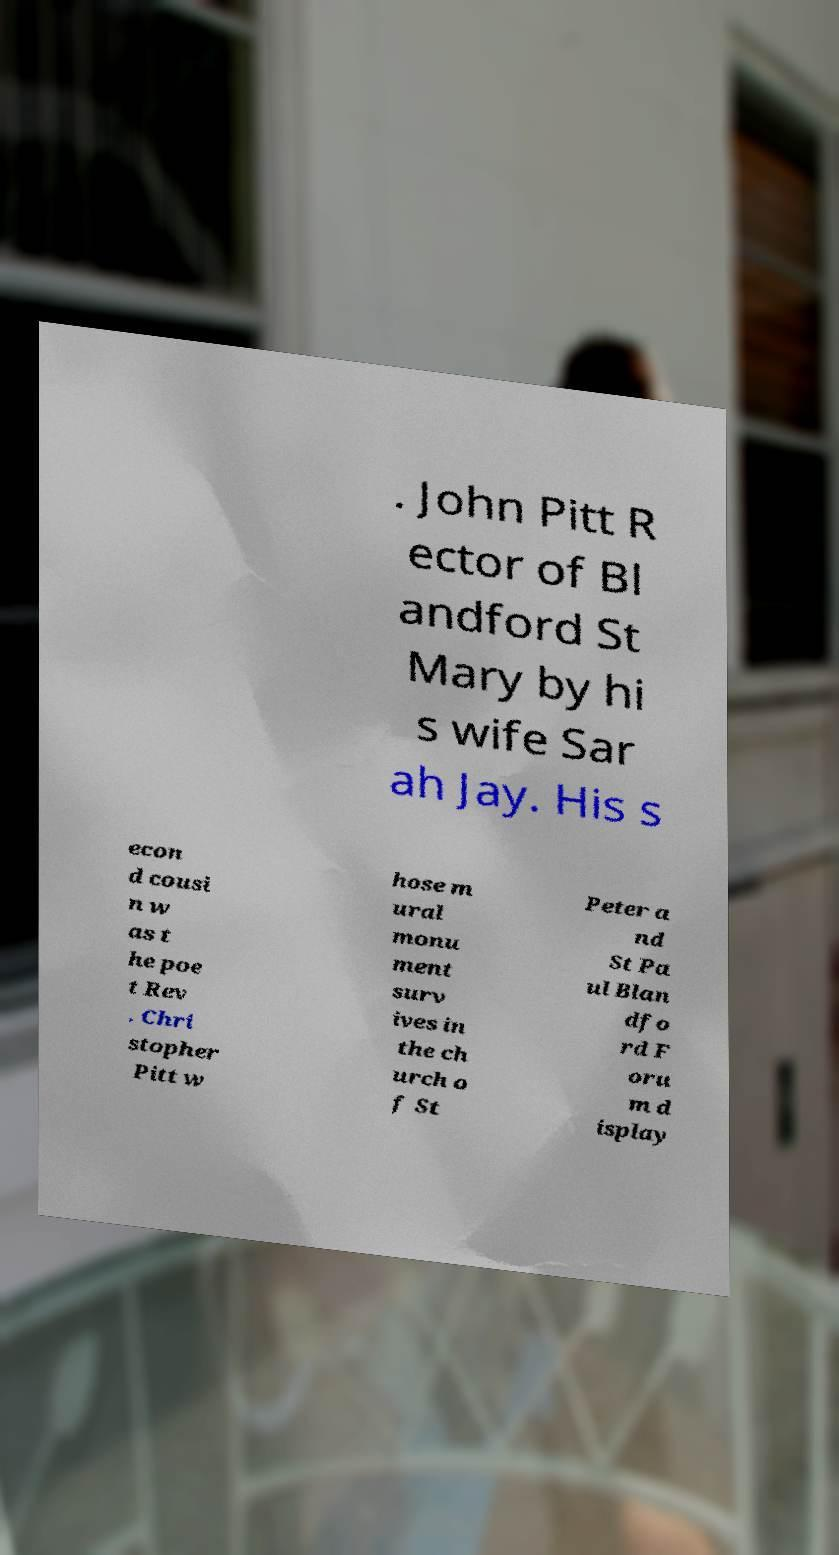What messages or text are displayed in this image? I need them in a readable, typed format. . John Pitt R ector of Bl andford St Mary by hi s wife Sar ah Jay. His s econ d cousi n w as t he poe t Rev . Chri stopher Pitt w hose m ural monu ment surv ives in the ch urch o f St Peter a nd St Pa ul Blan dfo rd F oru m d isplay 